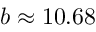<formula> <loc_0><loc_0><loc_500><loc_500>b \approx 1 0 . 6 8</formula> 